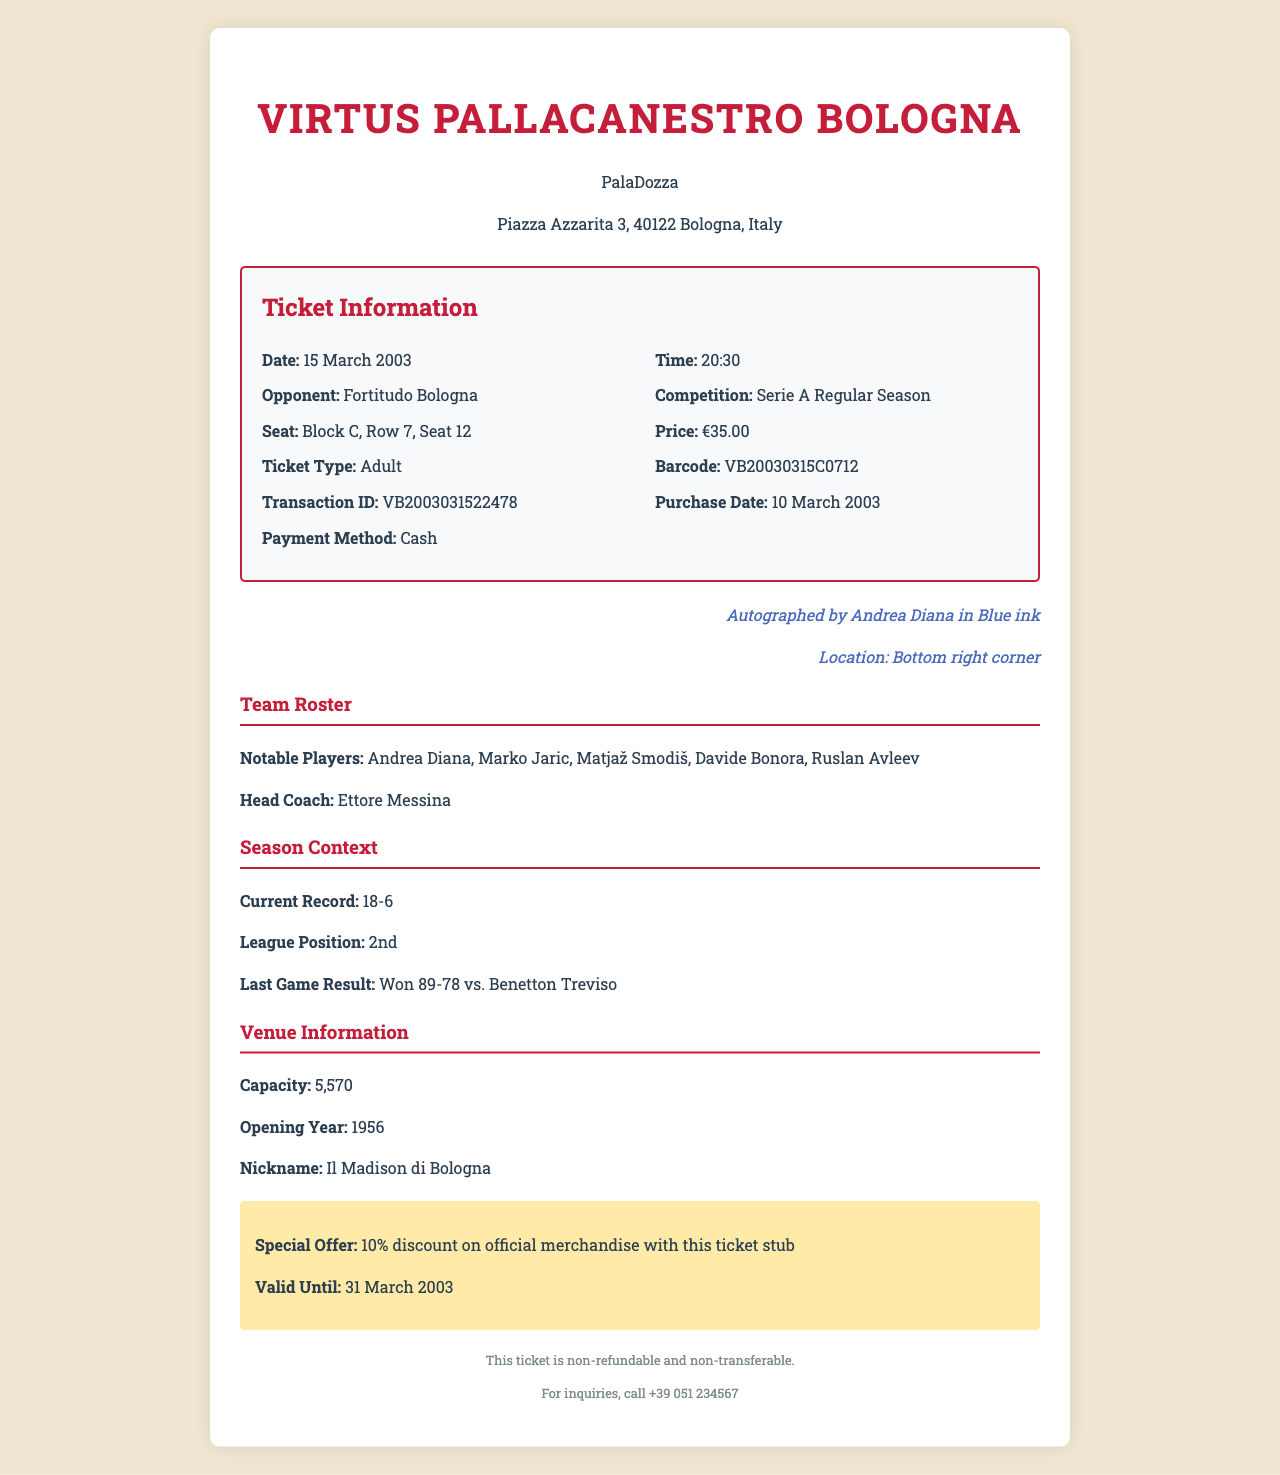What is the match date? The match date is specified in the game details section of the document.
Answer: 15 March 2003 Who is the opponent team? The opponent team is mentioned in the game details section of the document.
Answer: Fortitudo Bologna What is the seat number? The seat number is listed under the ticket information in the document.
Answer: Block C, Row 7, Seat 12 What color is Andrea Diana's autograph? The color of the autograph is mentioned in the special features section of the document.
Answer: Blue ink What is the current league position of Virtus Bologna? The league position is provided in the season context section of the document.
Answer: 2nd What is the ticket price? The ticket price can be found in the ticket information section of the document.
Answer: €35.00 What is the special offer provided with the ticket stub? The special offer is detailed in the promotions section of the document.
Answer: 10% discount on official merchandise What is the venue's nickname? The venue nickname is listed in the venue information section of the document.
Answer: Il Madison di Bologna How many notable players are listed in the team roster? The number of notable players can be counted from the team roster provided in the document.
Answer: 5 